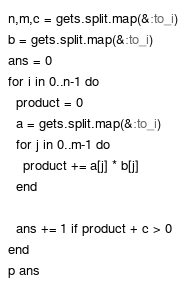<code> <loc_0><loc_0><loc_500><loc_500><_Ruby_>n,m,c = gets.split.map(&:to_i)
b = gets.split.map(&:to_i)
ans = 0
for i in 0..n-1 do
  product = 0
  a = gets.split.map(&:to_i)
  for j in 0..m-1 do
    product += a[j] * b[j]
  end
  
  ans += 1 if product + c > 0
end
p ans</code> 